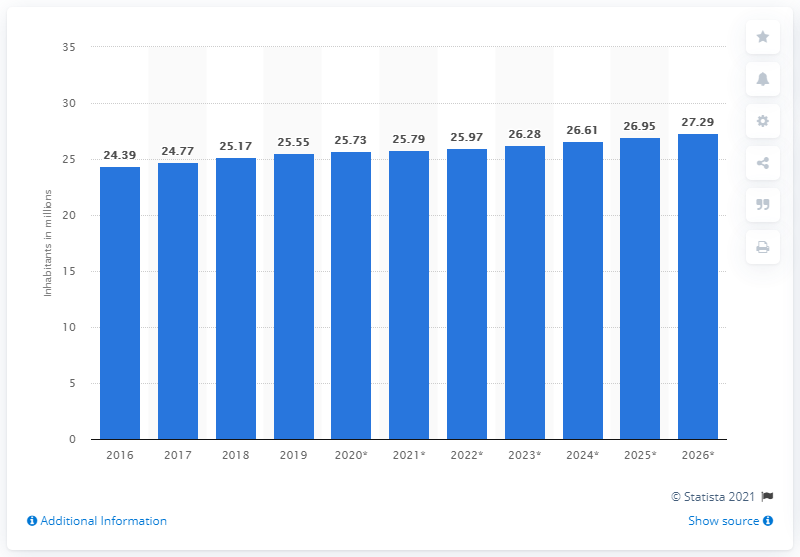Mention a couple of crucial points in this snapshot. As of 2019, the population of Australia was 25.79 million people. 